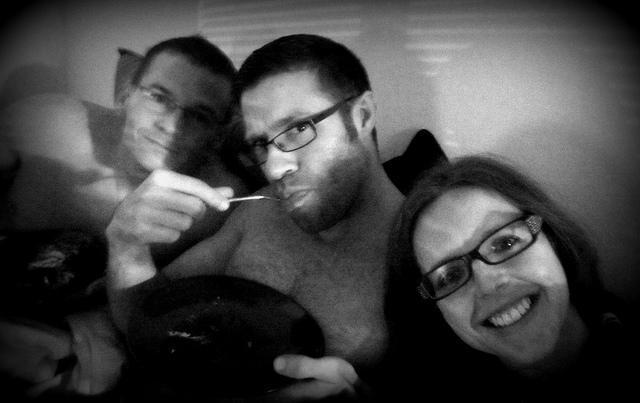How many people are wearing glasses?
Give a very brief answer. 3. How many people are in the photo?
Give a very brief answer. 3. How many cars have zebra stripes?
Give a very brief answer. 0. 